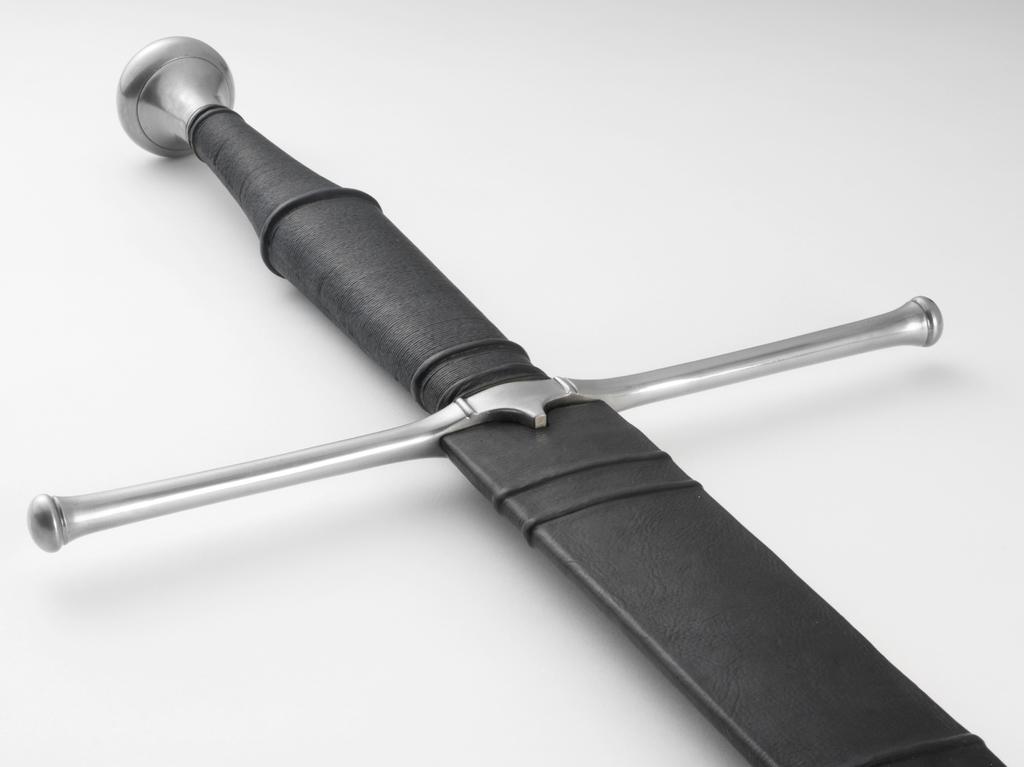How would you summarize this image in a sentence or two? In the picture we can see a sword with a handle which is black in color. 